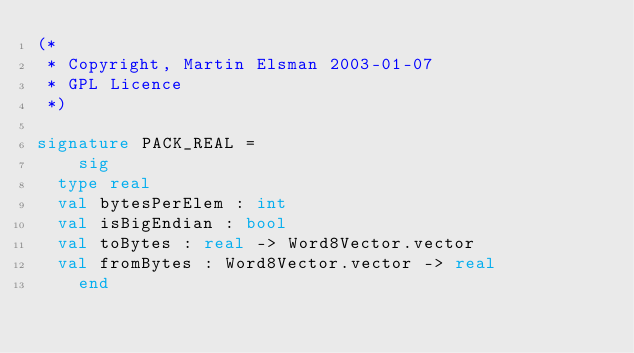<code> <loc_0><loc_0><loc_500><loc_500><_SML_>(*
 * Copyright, Martin Elsman 2003-01-07 
 * GPL Licence
 *)

signature PACK_REAL =
    sig
	type real
	val bytesPerElem : int
	val isBigEndian : bool
	val toBytes : real -> Word8Vector.vector
	val fromBytes : Word8Vector.vector -> real
    end
</code> 